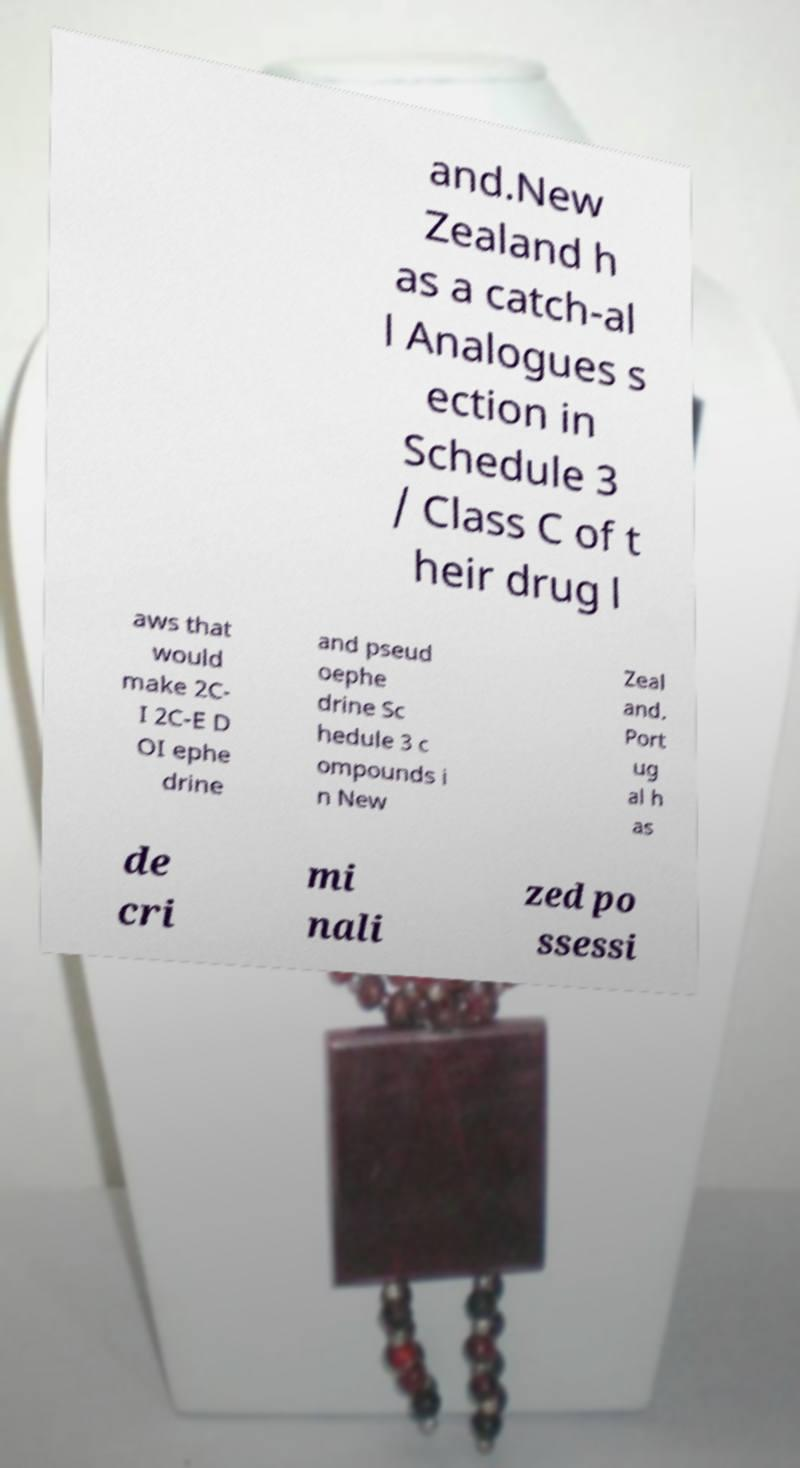Could you assist in decoding the text presented in this image and type it out clearly? and.New Zealand h as a catch-al l Analogues s ection in Schedule 3 / Class C of t heir drug l aws that would make 2C- I 2C-E D OI ephe drine and pseud oephe drine Sc hedule 3 c ompounds i n New Zeal and. Port ug al h as de cri mi nali zed po ssessi 